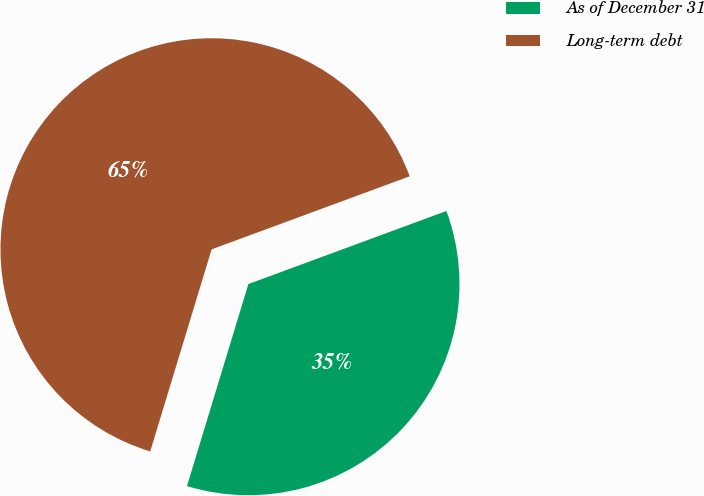Convert chart. <chart><loc_0><loc_0><loc_500><loc_500><pie_chart><fcel>As of December 31<fcel>Long-term debt<nl><fcel>35.32%<fcel>64.68%<nl></chart> 